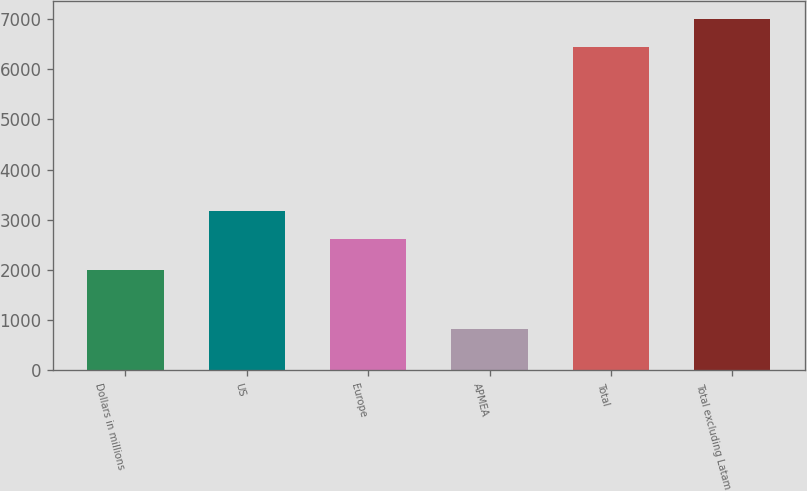<chart> <loc_0><loc_0><loc_500><loc_500><bar_chart><fcel>Dollars in millions<fcel>US<fcel>Europe<fcel>APMEA<fcel>Total<fcel>Total excluding Latam<nl><fcel>2008<fcel>3170.4<fcel>2608<fcel>819<fcel>6443<fcel>7005.4<nl></chart> 